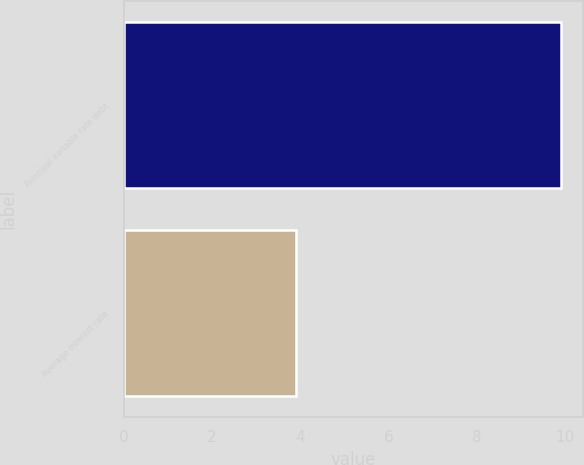Convert chart. <chart><loc_0><loc_0><loc_500><loc_500><bar_chart><fcel>Principal variable rate debt<fcel>Average interest rate<nl><fcel>9.9<fcel>3.9<nl></chart> 